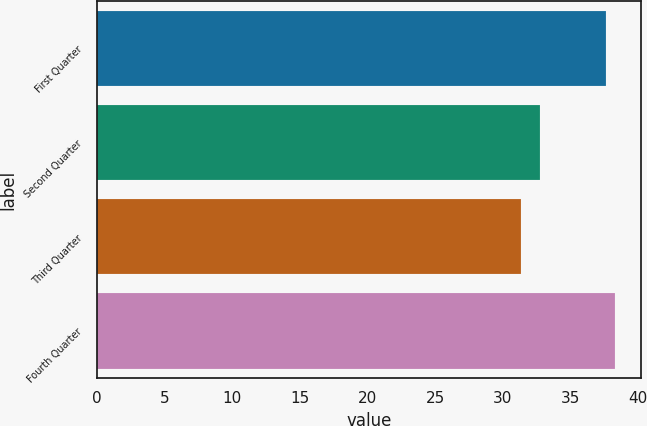Convert chart. <chart><loc_0><loc_0><loc_500><loc_500><bar_chart><fcel>First Quarter<fcel>Second Quarter<fcel>Third Quarter<fcel>Fourth Quarter<nl><fcel>37.6<fcel>32.73<fcel>31.36<fcel>38.29<nl></chart> 